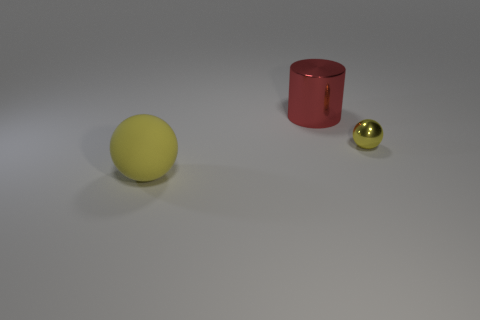Add 1 yellow metallic objects. How many objects exist? 4 Subtract all blue balls. Subtract all cyan cylinders. How many balls are left? 2 Subtract all balls. How many objects are left? 1 Add 1 large green cylinders. How many large green cylinders exist? 1 Subtract 0 red spheres. How many objects are left? 3 Subtract all tiny green rubber things. Subtract all red shiny objects. How many objects are left? 2 Add 1 tiny yellow balls. How many tiny yellow balls are left? 2 